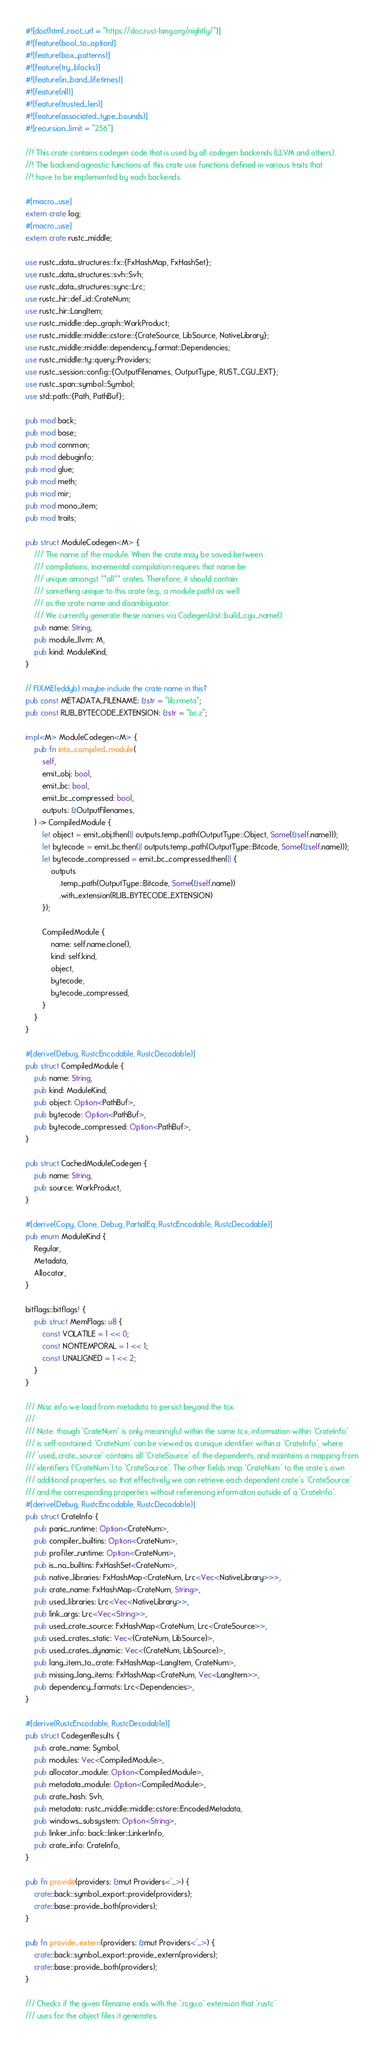Convert code to text. <code><loc_0><loc_0><loc_500><loc_500><_Rust_>#![doc(html_root_url = "https://doc.rust-lang.org/nightly/")]
#![feature(bool_to_option)]
#![feature(box_patterns)]
#![feature(try_blocks)]
#![feature(in_band_lifetimes)]
#![feature(nll)]
#![feature(trusted_len)]
#![feature(associated_type_bounds)]
#![recursion_limit = "256"]

//! This crate contains codegen code that is used by all codegen backends (LLVM and others).
//! The backend-agnostic functions of this crate use functions defined in various traits that
//! have to be implemented by each backends.

#[macro_use]
extern crate log;
#[macro_use]
extern crate rustc_middle;

use rustc_data_structures::fx::{FxHashMap, FxHashSet};
use rustc_data_structures::svh::Svh;
use rustc_data_structures::sync::Lrc;
use rustc_hir::def_id::CrateNum;
use rustc_hir::LangItem;
use rustc_middle::dep_graph::WorkProduct;
use rustc_middle::middle::cstore::{CrateSource, LibSource, NativeLibrary};
use rustc_middle::middle::dependency_format::Dependencies;
use rustc_middle::ty::query::Providers;
use rustc_session::config::{OutputFilenames, OutputType, RUST_CGU_EXT};
use rustc_span::symbol::Symbol;
use std::path::{Path, PathBuf};

pub mod back;
pub mod base;
pub mod common;
pub mod debuginfo;
pub mod glue;
pub mod meth;
pub mod mir;
pub mod mono_item;
pub mod traits;

pub struct ModuleCodegen<M> {
    /// The name of the module. When the crate may be saved between
    /// compilations, incremental compilation requires that name be
    /// unique amongst **all** crates. Therefore, it should contain
    /// something unique to this crate (e.g., a module path) as well
    /// as the crate name and disambiguator.
    /// We currently generate these names via CodegenUnit::build_cgu_name().
    pub name: String,
    pub module_llvm: M,
    pub kind: ModuleKind,
}

// FIXME(eddyb) maybe include the crate name in this?
pub const METADATA_FILENAME: &str = "lib.rmeta";
pub const RLIB_BYTECODE_EXTENSION: &str = "bc.z";

impl<M> ModuleCodegen<M> {
    pub fn into_compiled_module(
        self,
        emit_obj: bool,
        emit_bc: bool,
        emit_bc_compressed: bool,
        outputs: &OutputFilenames,
    ) -> CompiledModule {
        let object = emit_obj.then(|| outputs.temp_path(OutputType::Object, Some(&self.name)));
        let bytecode = emit_bc.then(|| outputs.temp_path(OutputType::Bitcode, Some(&self.name)));
        let bytecode_compressed = emit_bc_compressed.then(|| {
            outputs
                .temp_path(OutputType::Bitcode, Some(&self.name))
                .with_extension(RLIB_BYTECODE_EXTENSION)
        });

        CompiledModule {
            name: self.name.clone(),
            kind: self.kind,
            object,
            bytecode,
            bytecode_compressed,
        }
    }
}

#[derive(Debug, RustcEncodable, RustcDecodable)]
pub struct CompiledModule {
    pub name: String,
    pub kind: ModuleKind,
    pub object: Option<PathBuf>,
    pub bytecode: Option<PathBuf>,
    pub bytecode_compressed: Option<PathBuf>,
}

pub struct CachedModuleCodegen {
    pub name: String,
    pub source: WorkProduct,
}

#[derive(Copy, Clone, Debug, PartialEq, RustcEncodable, RustcDecodable)]
pub enum ModuleKind {
    Regular,
    Metadata,
    Allocator,
}

bitflags::bitflags! {
    pub struct MemFlags: u8 {
        const VOLATILE = 1 << 0;
        const NONTEMPORAL = 1 << 1;
        const UNALIGNED = 1 << 2;
    }
}

/// Misc info we load from metadata to persist beyond the tcx.
///
/// Note: though `CrateNum` is only meaningful within the same tcx, information within `CrateInfo`
/// is self-contained. `CrateNum` can be viewed as a unique identifier within a `CrateInfo`, where
/// `used_crate_source` contains all `CrateSource` of the dependents, and maintains a mapping from
/// identifiers (`CrateNum`) to `CrateSource`. The other fields map `CrateNum` to the crate's own
/// additional properties, so that effectively we can retrieve each dependent crate's `CrateSource`
/// and the corresponding properties without referencing information outside of a `CrateInfo`.
#[derive(Debug, RustcEncodable, RustcDecodable)]
pub struct CrateInfo {
    pub panic_runtime: Option<CrateNum>,
    pub compiler_builtins: Option<CrateNum>,
    pub profiler_runtime: Option<CrateNum>,
    pub is_no_builtins: FxHashSet<CrateNum>,
    pub native_libraries: FxHashMap<CrateNum, Lrc<Vec<NativeLibrary>>>,
    pub crate_name: FxHashMap<CrateNum, String>,
    pub used_libraries: Lrc<Vec<NativeLibrary>>,
    pub link_args: Lrc<Vec<String>>,
    pub used_crate_source: FxHashMap<CrateNum, Lrc<CrateSource>>,
    pub used_crates_static: Vec<(CrateNum, LibSource)>,
    pub used_crates_dynamic: Vec<(CrateNum, LibSource)>,
    pub lang_item_to_crate: FxHashMap<LangItem, CrateNum>,
    pub missing_lang_items: FxHashMap<CrateNum, Vec<LangItem>>,
    pub dependency_formats: Lrc<Dependencies>,
}

#[derive(RustcEncodable, RustcDecodable)]
pub struct CodegenResults {
    pub crate_name: Symbol,
    pub modules: Vec<CompiledModule>,
    pub allocator_module: Option<CompiledModule>,
    pub metadata_module: Option<CompiledModule>,
    pub crate_hash: Svh,
    pub metadata: rustc_middle::middle::cstore::EncodedMetadata,
    pub windows_subsystem: Option<String>,
    pub linker_info: back::linker::LinkerInfo,
    pub crate_info: CrateInfo,
}

pub fn provide(providers: &mut Providers<'_>) {
    crate::back::symbol_export::provide(providers);
    crate::base::provide_both(providers);
}

pub fn provide_extern(providers: &mut Providers<'_>) {
    crate::back::symbol_export::provide_extern(providers);
    crate::base::provide_both(providers);
}

/// Checks if the given filename ends with the `.rcgu.o` extension that `rustc`
/// uses for the object files it generates.</code> 